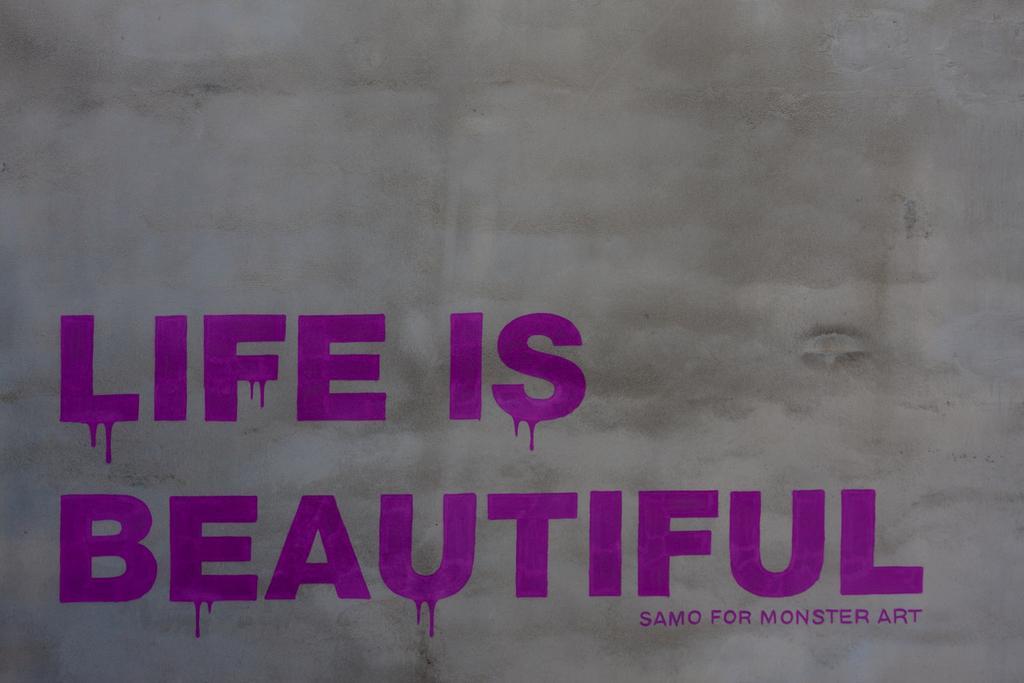Please provide a concise description of this image. In this picture we can see a wall, on this wall we can see some text on it. 